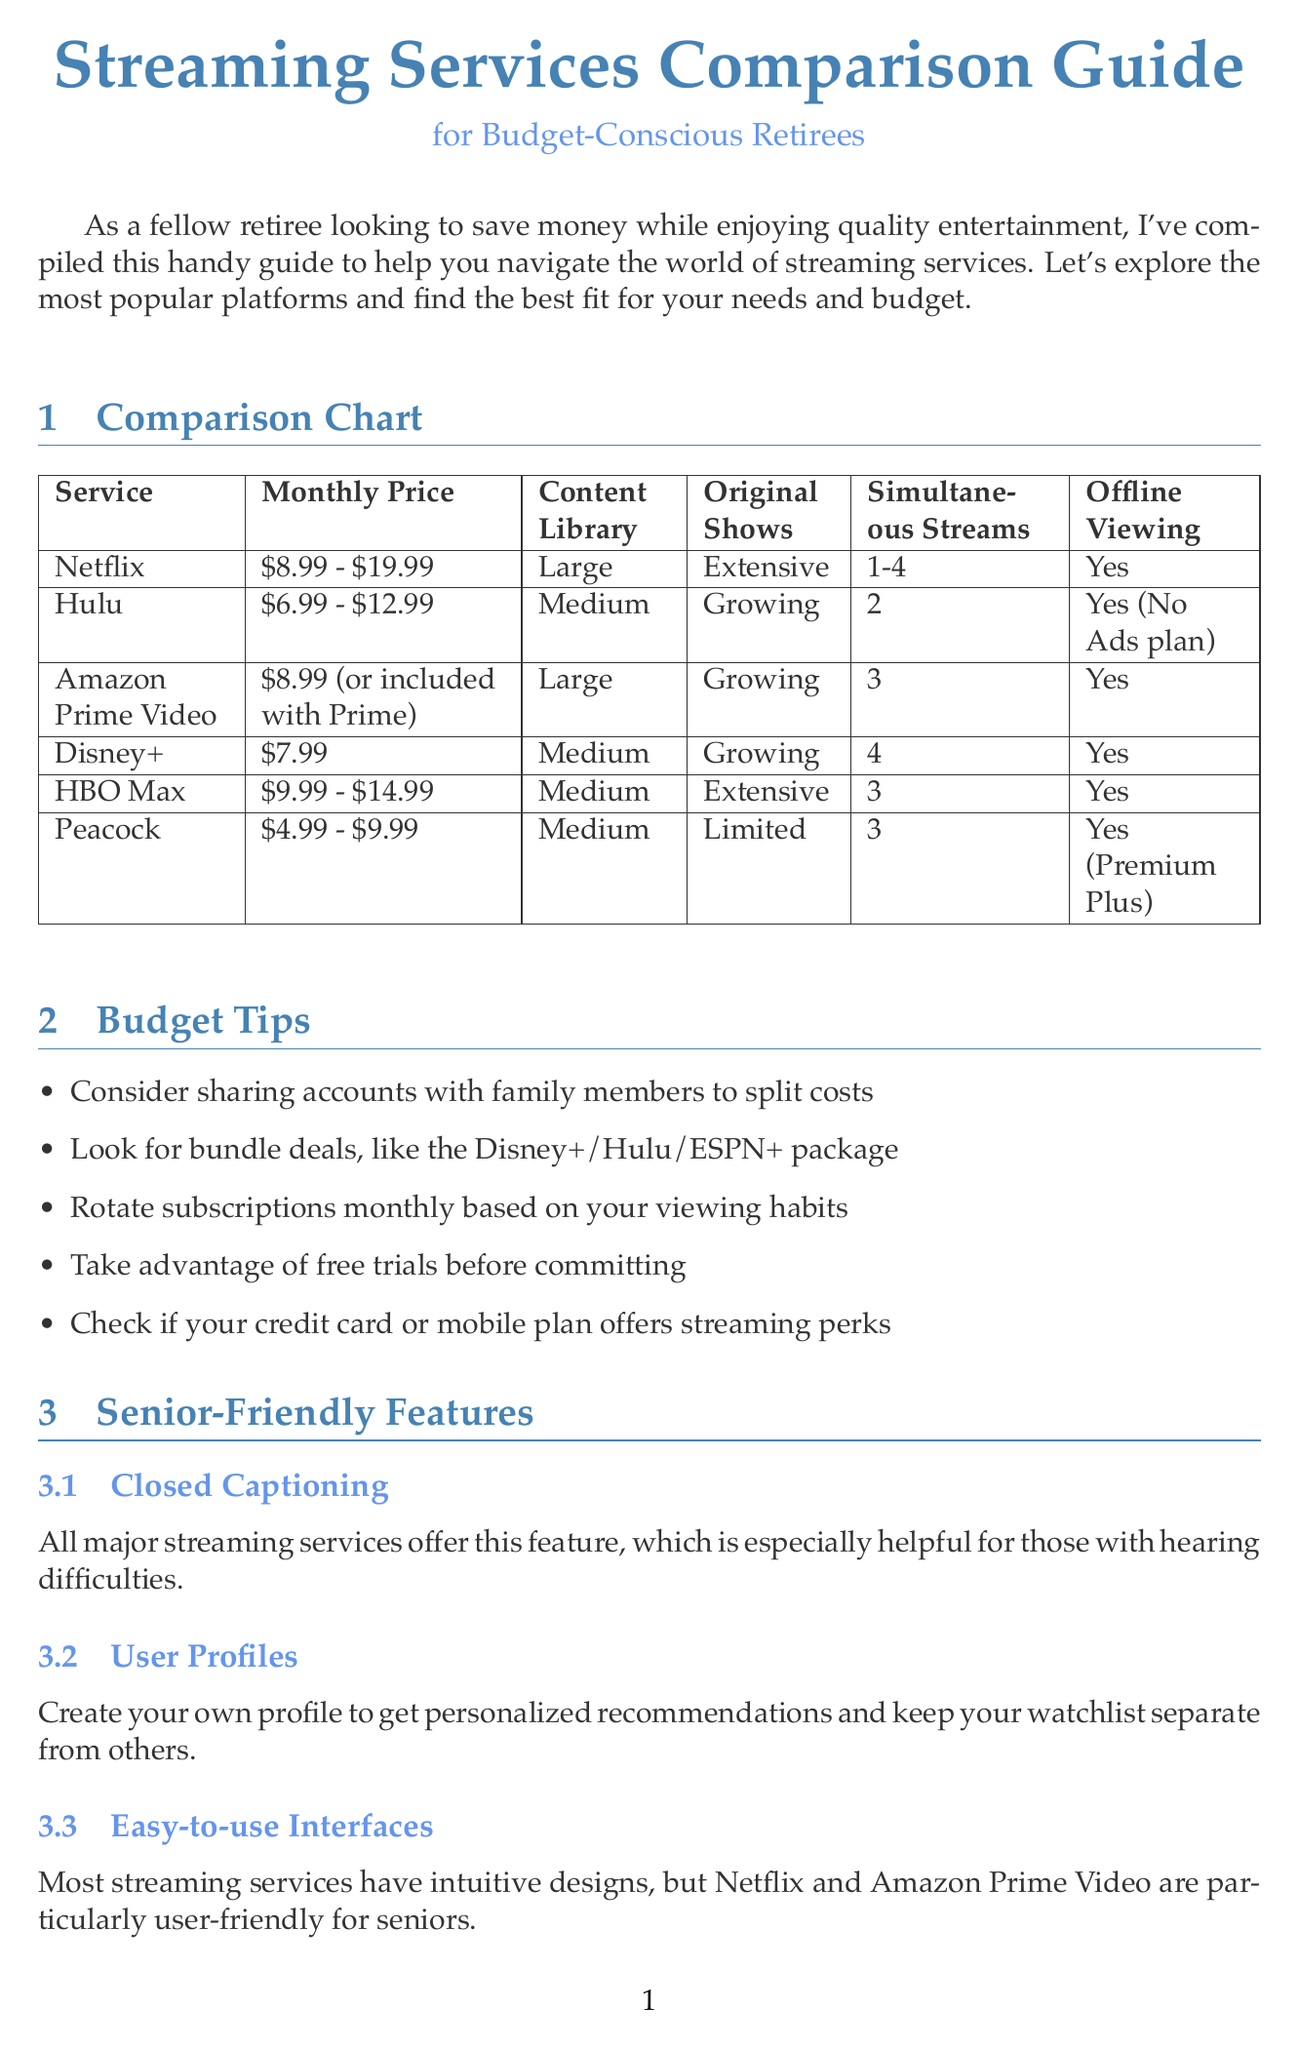What is the title of the newsletter? The title of the newsletter is mentioned at the top of the document.
Answer: Streaming Services Comparison Guide for Budget-Conscious Retirees What is the monthly price range for Netflix? The monthly price range for Netflix is provided in the comparison chart.
Answer: $8.99 - $19.99 How many simultaneous streams does Peacock allow? The number of simultaneous streams for Peacock can be found in the comparison chart.
Answer: 3 Which platform offers "The Golden Girls"? The platform for "The Golden Girls" is listed under popular shows for seniors.
Answer: Hulu What is a tip provided for saving money on streaming services? The budget tips list several ways to save money, one of which is specified.
Answer: Consider sharing accounts with family members to split costs Which streaming service is noted for its extensive original shows? The comparison chart indicates which service has extensive original shows.
Answer: Netflix Which platform has the lowest starting monthly price? The monthly prices for each service are compared to find the lowest.
Answer: Peacock What feature helps those with hearing difficulties across all services? The senior-friendly features section mentions a specific feature that aids those with hearing difficulties.
Answer: Closed Captioning What is one popular show listed that features a comedic duo? The popular shows for seniors section includes a specific comedy series focusing on two women.
Answer: Grace and Frankie 